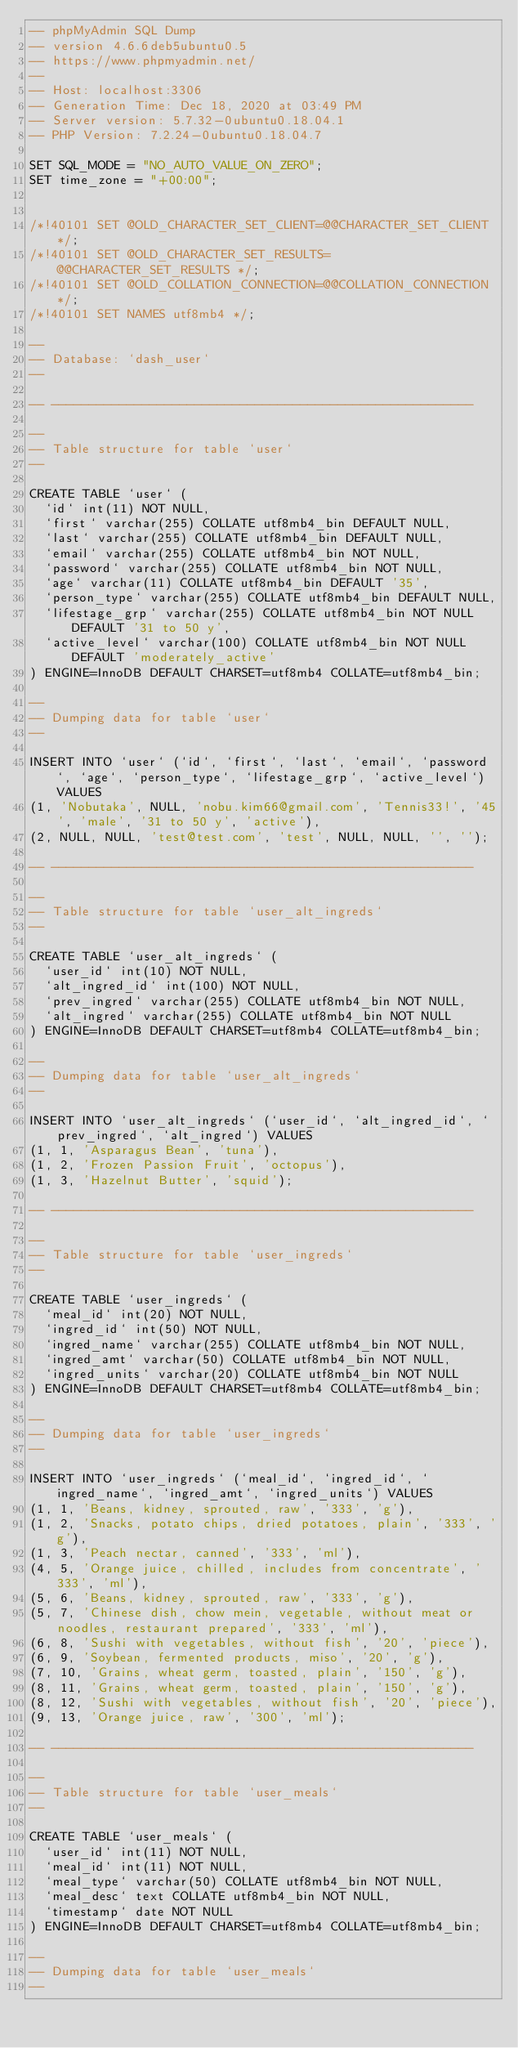Convert code to text. <code><loc_0><loc_0><loc_500><loc_500><_SQL_>-- phpMyAdmin SQL Dump
-- version 4.6.6deb5ubuntu0.5
-- https://www.phpmyadmin.net/
--
-- Host: localhost:3306
-- Generation Time: Dec 18, 2020 at 03:49 PM
-- Server version: 5.7.32-0ubuntu0.18.04.1
-- PHP Version: 7.2.24-0ubuntu0.18.04.7

SET SQL_MODE = "NO_AUTO_VALUE_ON_ZERO";
SET time_zone = "+00:00";


/*!40101 SET @OLD_CHARACTER_SET_CLIENT=@@CHARACTER_SET_CLIENT */;
/*!40101 SET @OLD_CHARACTER_SET_RESULTS=@@CHARACTER_SET_RESULTS */;
/*!40101 SET @OLD_COLLATION_CONNECTION=@@COLLATION_CONNECTION */;
/*!40101 SET NAMES utf8mb4 */;

--
-- Database: `dash_user`
--

-- --------------------------------------------------------

--
-- Table structure for table `user`
--

CREATE TABLE `user` (
  `id` int(11) NOT NULL,
  `first` varchar(255) COLLATE utf8mb4_bin DEFAULT NULL,
  `last` varchar(255) COLLATE utf8mb4_bin DEFAULT NULL,
  `email` varchar(255) COLLATE utf8mb4_bin NOT NULL,
  `password` varchar(255) COLLATE utf8mb4_bin NOT NULL,
  `age` varchar(11) COLLATE utf8mb4_bin DEFAULT '35',
  `person_type` varchar(255) COLLATE utf8mb4_bin DEFAULT NULL,
  `lifestage_grp` varchar(255) COLLATE utf8mb4_bin NOT NULL DEFAULT '31 to 50 y',
  `active_level` varchar(100) COLLATE utf8mb4_bin NOT NULL DEFAULT 'moderately_active'
) ENGINE=InnoDB DEFAULT CHARSET=utf8mb4 COLLATE=utf8mb4_bin;

--
-- Dumping data for table `user`
--

INSERT INTO `user` (`id`, `first`, `last`, `email`, `password`, `age`, `person_type`, `lifestage_grp`, `active_level`) VALUES
(1, 'Nobutaka', NULL, 'nobu.kim66@gmail.com', 'Tennis33!', '45', 'male', '31 to 50 y', 'active'),
(2, NULL, NULL, 'test@test.com', 'test', NULL, NULL, '', '');

-- --------------------------------------------------------

--
-- Table structure for table `user_alt_ingreds`
--

CREATE TABLE `user_alt_ingreds` (
  `user_id` int(10) NOT NULL,
  `alt_ingred_id` int(100) NOT NULL,
  `prev_ingred` varchar(255) COLLATE utf8mb4_bin NOT NULL,
  `alt_ingred` varchar(255) COLLATE utf8mb4_bin NOT NULL
) ENGINE=InnoDB DEFAULT CHARSET=utf8mb4 COLLATE=utf8mb4_bin;

--
-- Dumping data for table `user_alt_ingreds`
--

INSERT INTO `user_alt_ingreds` (`user_id`, `alt_ingred_id`, `prev_ingred`, `alt_ingred`) VALUES
(1, 1, 'Asparagus Bean', 'tuna'),
(1, 2, 'Frozen Passion Fruit', 'octopus'),
(1, 3, 'Hazelnut Butter', 'squid');

-- --------------------------------------------------------

--
-- Table structure for table `user_ingreds`
--

CREATE TABLE `user_ingreds` (
  `meal_id` int(20) NOT NULL,
  `ingred_id` int(50) NOT NULL,
  `ingred_name` varchar(255) COLLATE utf8mb4_bin NOT NULL,
  `ingred_amt` varchar(50) COLLATE utf8mb4_bin NOT NULL,
  `ingred_units` varchar(20) COLLATE utf8mb4_bin NOT NULL
) ENGINE=InnoDB DEFAULT CHARSET=utf8mb4 COLLATE=utf8mb4_bin;

--
-- Dumping data for table `user_ingreds`
--

INSERT INTO `user_ingreds` (`meal_id`, `ingred_id`, `ingred_name`, `ingred_amt`, `ingred_units`) VALUES
(1, 1, 'Beans, kidney, sprouted, raw', '333', 'g'),
(1, 2, 'Snacks, potato chips, dried potatoes, plain', '333', 'g'),
(1, 3, 'Peach nectar, canned', '333', 'ml'),
(4, 5, 'Orange juice, chilled, includes from concentrate', '333', 'ml'),
(5, 6, 'Beans, kidney, sprouted, raw', '333', 'g'),
(5, 7, 'Chinese dish, chow mein, vegetable, without meat or noodles, restaurant prepared', '333', 'ml'),
(6, 8, 'Sushi with vegetables, without fish', '20', 'piece'),
(6, 9, 'Soybean, fermented products, miso', '20', 'g'),
(7, 10, 'Grains, wheat germ, toasted, plain', '150', 'g'),
(8, 11, 'Grains, wheat germ, toasted, plain', '150', 'g'),
(8, 12, 'Sushi with vegetables, without fish', '20', 'piece'),
(9, 13, 'Orange juice, raw', '300', 'ml');

-- --------------------------------------------------------

--
-- Table structure for table `user_meals`
--

CREATE TABLE `user_meals` (
  `user_id` int(11) NOT NULL,
  `meal_id` int(11) NOT NULL,
  `meal_type` varchar(50) COLLATE utf8mb4_bin NOT NULL,
  `meal_desc` text COLLATE utf8mb4_bin NOT NULL,
  `timestamp` date NOT NULL
) ENGINE=InnoDB DEFAULT CHARSET=utf8mb4 COLLATE=utf8mb4_bin;

--
-- Dumping data for table `user_meals`
--
</code> 